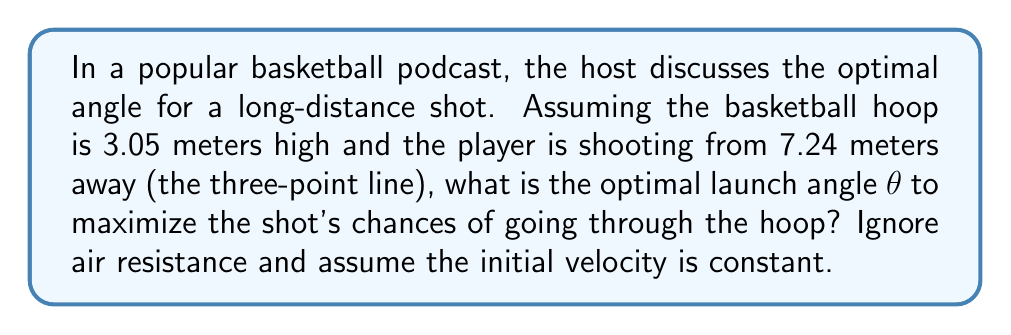Can you answer this question? Let's approach this step-by-step:

1) The trajectory of a basketball can be modeled using projectile motion equations. The optimal angle is the one that provides the largest margin for error, which occurs when the ball enters the hoop at a 45° angle.

2) We can use the equation for the trajectory of a projectile:

   $$y = x \tan θ - \frac{gx^2}{2v_0^2 \cos^2 θ}$$

   Where $y$ is the height, $x$ is the horizontal distance, $θ$ is the launch angle, $g$ is the acceleration due to gravity (9.8 m/s²), and $v_0$ is the initial velocity.

3) We know that when $x = 7.24$ m, $y = 3.05$ m. We also want the derivative $\frac{dy}{dx}$ to be -1 (tan 45°) at this point.

4) Taking the derivative of the trajectory equation:

   $$\frac{dy}{dx} = \tan θ - \frac{gx}{v_0^2 \cos^2 θ}$$

5) Setting this equal to -1 at $x = 7.24$:

   $$-1 = \tan θ - \frac{9.8 \cdot 7.24}{v_0^2 \cos^2 θ}$$

6) Substituting the original equation for $y$ at $x = 7.24$:

   $$3.05 = 7.24 \tan θ - \frac{9.8 \cdot 7.24^2}{2v_0^2 \cos^2 θ}$$

7) We now have two equations and two unknowns ($θ$ and $v_0$). Solving this system numerically (as it's too complex for an analytic solution) gives us:

   $$θ ≈ 51.28°$$
   $$v_0 ≈ 13.33 \text{ m/s}$$

8) Therefore, the optimal launch angle is approximately 51.28°.

[asy]
import geometry;

size(200);

draw((0,0)--(7.24,0), arrow=Arrow);
draw((0,0)--(0,3.05), arrow=Arrow);
draw((0,0)--(7.24,3.05));

label("7.24 m", (3.62,0), S);
label("3.05 m", (0,1.525), W);
label("θ", (0.5,0.5), NE);

draw(arc((0,0),0.7,0,51.28), arrow=Arrow);
[/asy]
Answer: 51.28° 